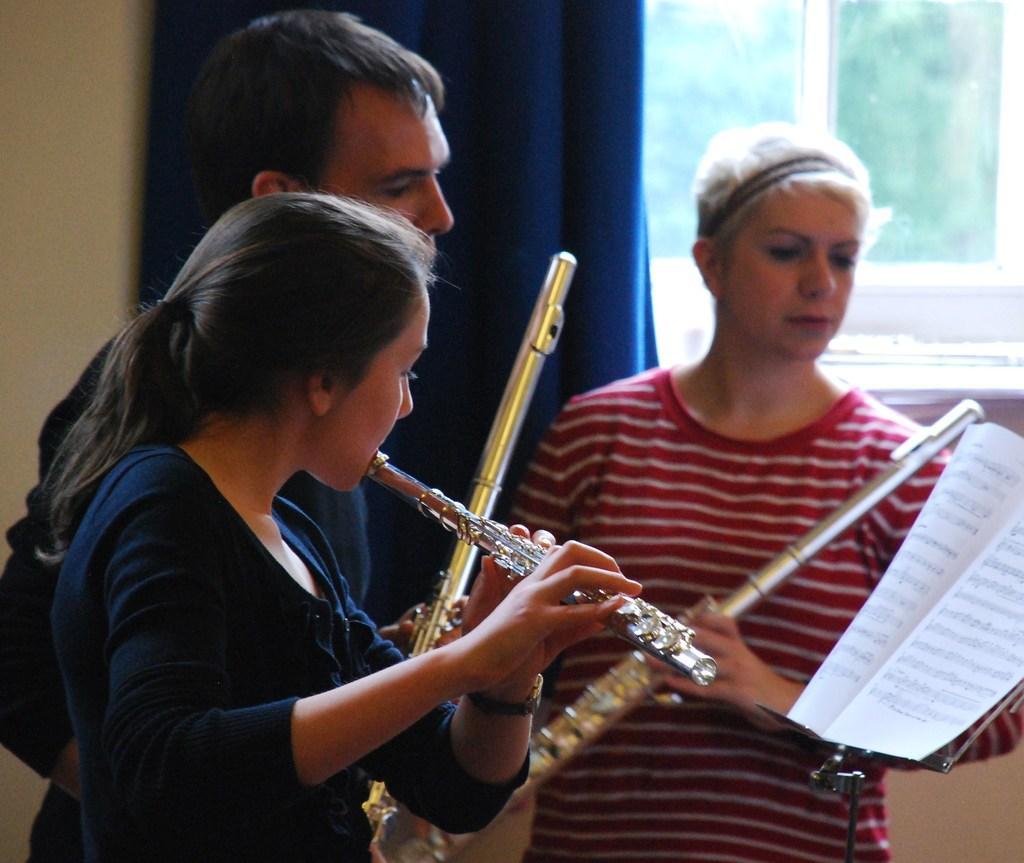Describe this image in one or two sentences. In this image I can see there are two women and a man. The woman in the black dress is playing a musical instrument and others are holding the musical instrument. 